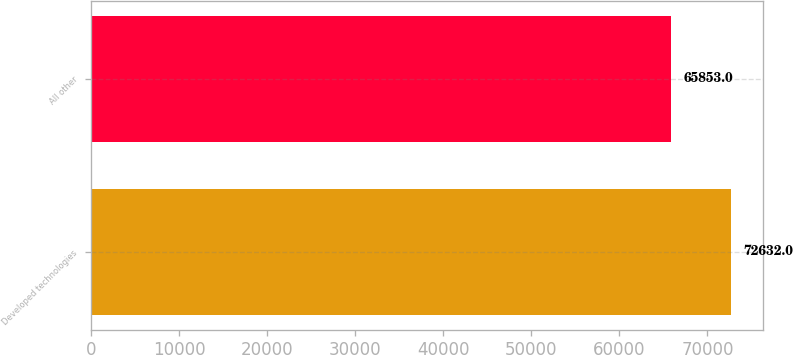<chart> <loc_0><loc_0><loc_500><loc_500><bar_chart><fcel>Developed technologies<fcel>All other<nl><fcel>72632<fcel>65853<nl></chart> 